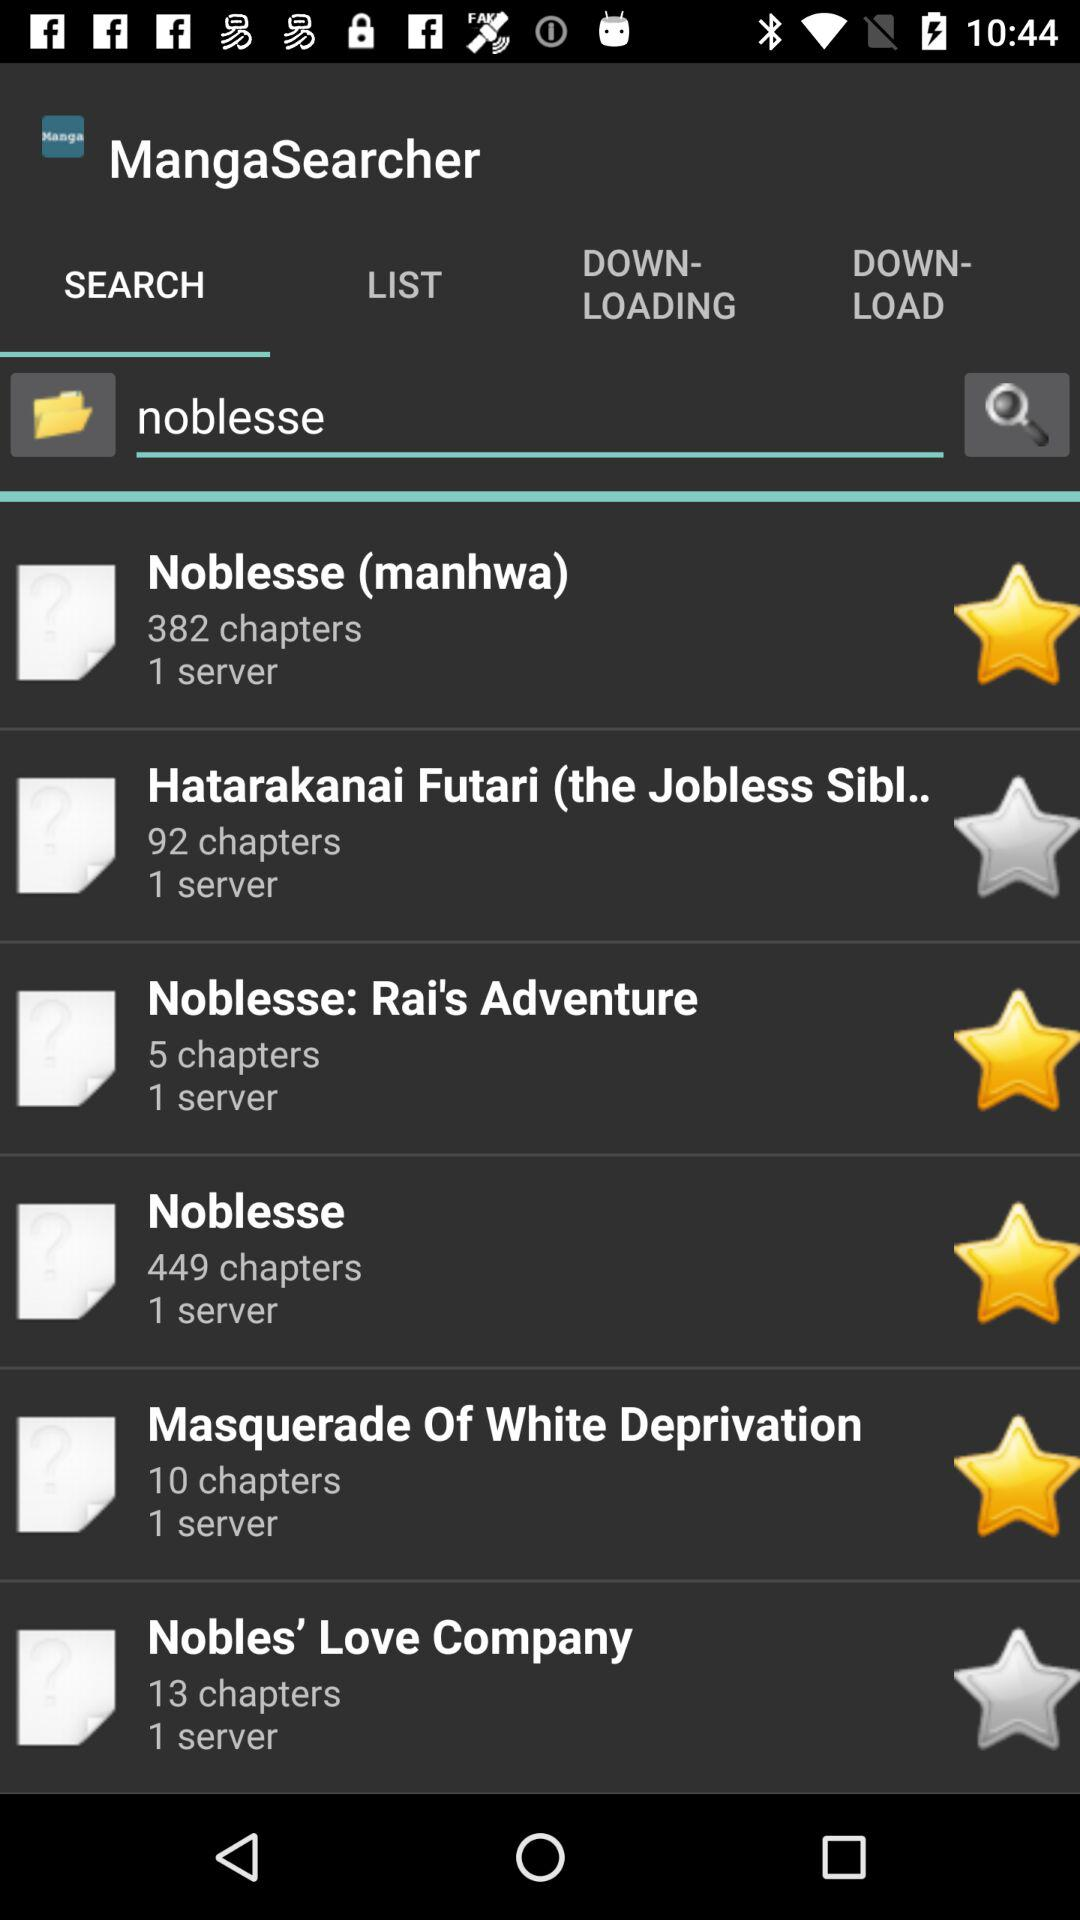How many chapters does the manga with the least chapters have?
Answer the question using a single word or phrase. 5 